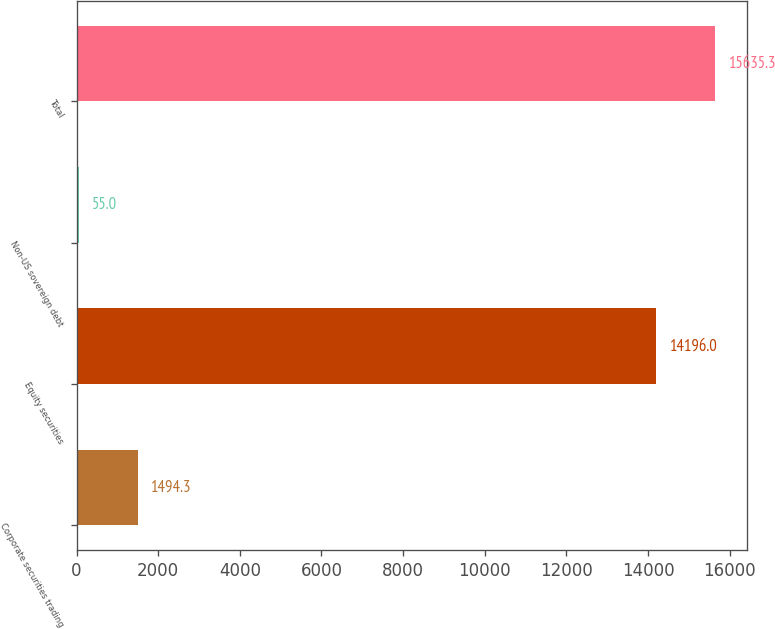<chart> <loc_0><loc_0><loc_500><loc_500><bar_chart><fcel>Corporate securities trading<fcel>Equity securities<fcel>Non-US sovereign debt<fcel>Total<nl><fcel>1494.3<fcel>14196<fcel>55<fcel>15635.3<nl></chart> 